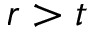Convert formula to latex. <formula><loc_0><loc_0><loc_500><loc_500>r > t</formula> 